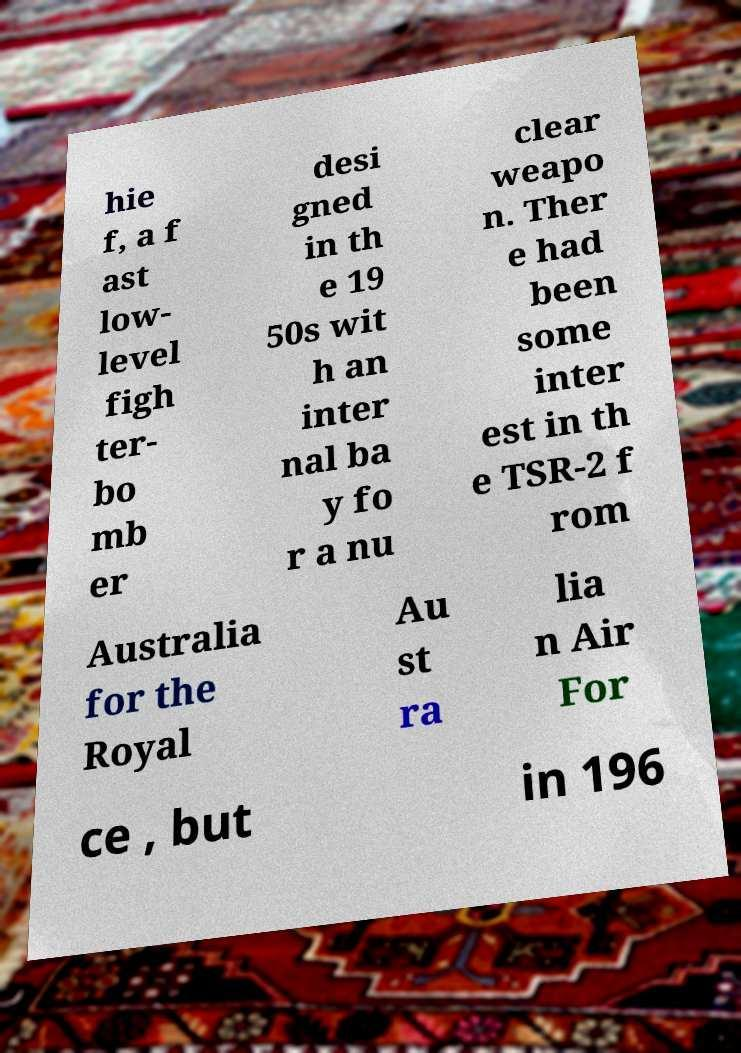There's text embedded in this image that I need extracted. Can you transcribe it verbatim? hie f, a f ast low- level figh ter- bo mb er desi gned in th e 19 50s wit h an inter nal ba y fo r a nu clear weapo n. Ther e had been some inter est in th e TSR-2 f rom Australia for the Royal Au st ra lia n Air For ce , but in 196 